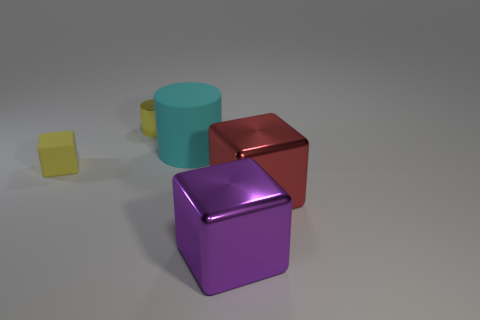Add 1 green rubber objects. How many objects exist? 6 Subtract all cylinders. How many objects are left? 3 Add 3 yellow rubber blocks. How many yellow rubber blocks exist? 4 Subtract 1 cyan cylinders. How many objects are left? 4 Subtract all tiny spheres. Subtract all large purple blocks. How many objects are left? 4 Add 4 yellow objects. How many yellow objects are left? 6 